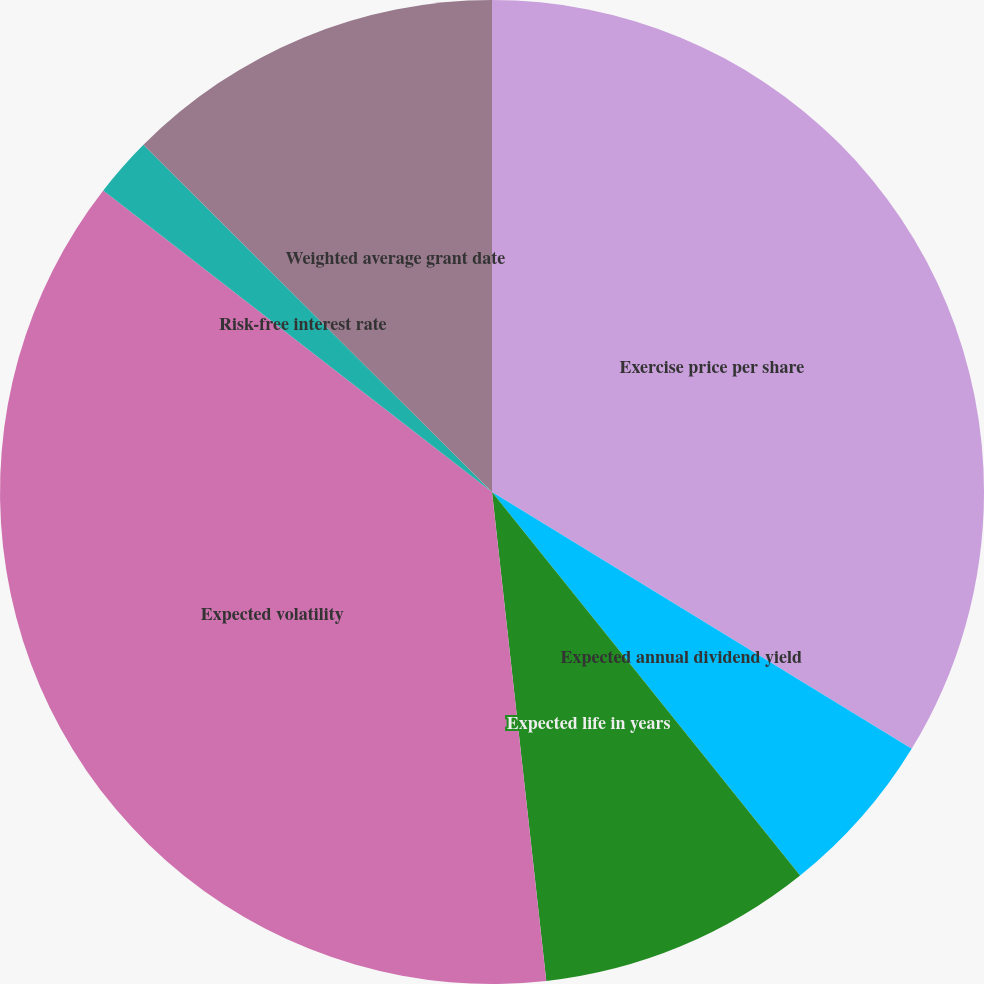<chart> <loc_0><loc_0><loc_500><loc_500><pie_chart><fcel>Exercise price per share<fcel>Expected annual dividend yield<fcel>Expected life in years<fcel>Expected volatility<fcel>Risk-free interest rate<fcel>Weighted average grant date<nl><fcel>33.74%<fcel>5.49%<fcel>9.01%<fcel>37.26%<fcel>1.97%<fcel>12.53%<nl></chart> 